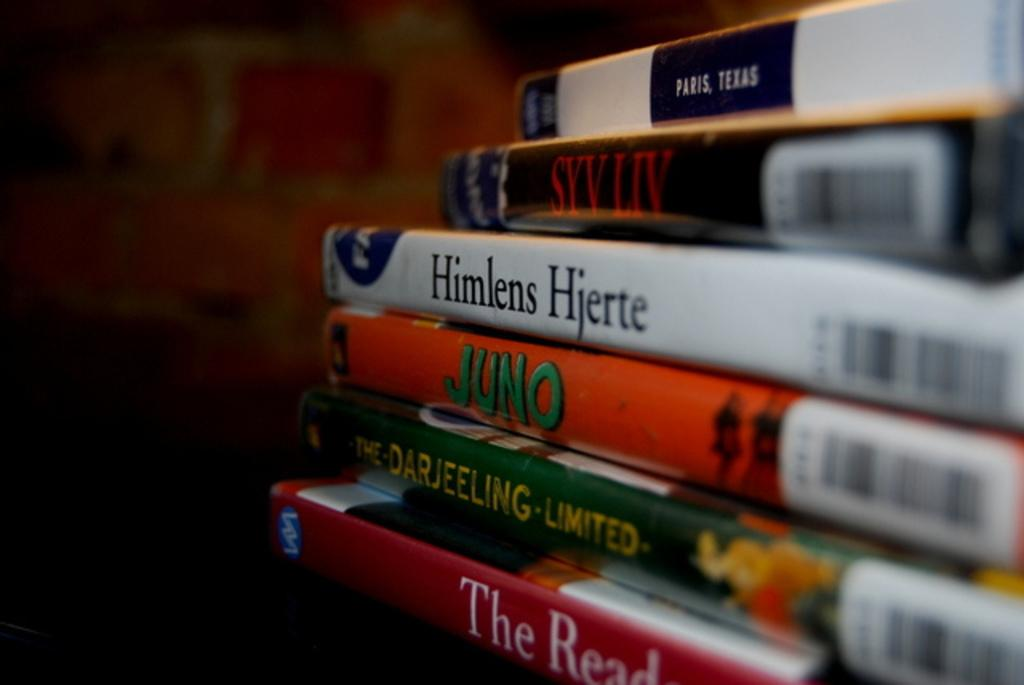<image>
Summarize the visual content of the image. A stack of DVDs including the movie Juno and Himlens Hjerte, 